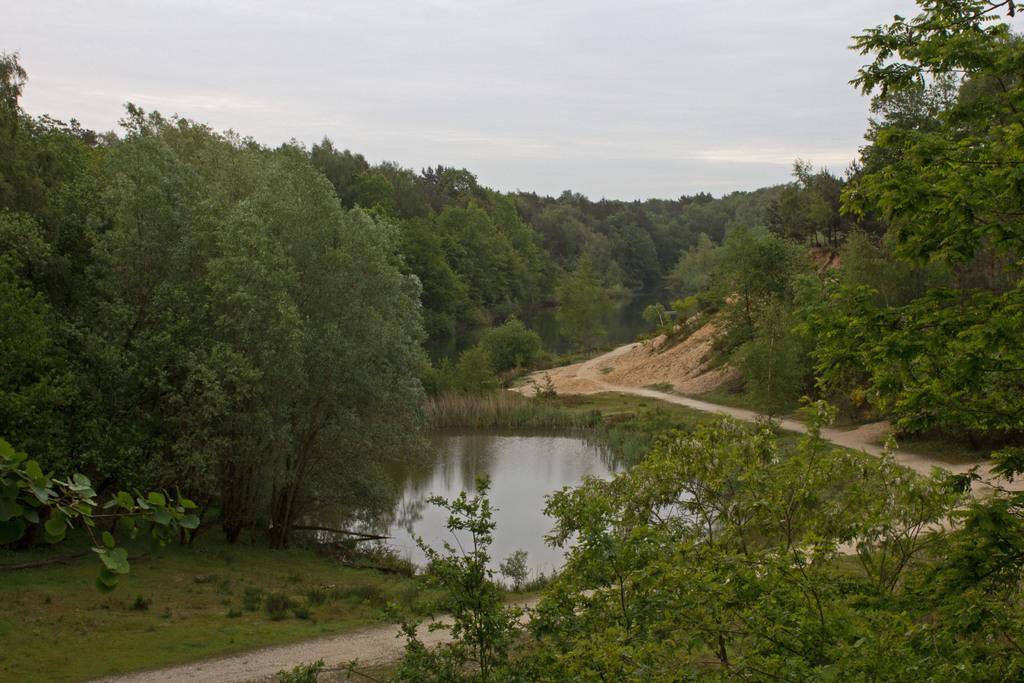What type of vegetation can be seen in the image? There are trees in the image. What natural element is visible in the image? There is water visible in the image. Is there any man-made structure or feature in the image? Yes, there is a path in the image. What type of light can be seen reflecting off the water in the image? There is no specific light source mentioned in the image, and the reflection of light cannot be determined from the provided facts. Can you see someone's elbow in the image? There is no mention of any person or body part in the image, so it is not possible to see someone's elbow. 